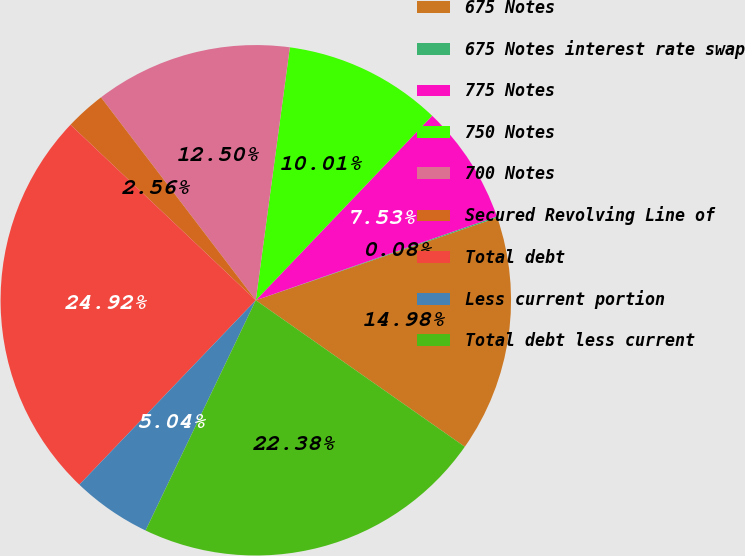<chart> <loc_0><loc_0><loc_500><loc_500><pie_chart><fcel>675 Notes<fcel>675 Notes interest rate swap<fcel>775 Notes<fcel>750 Notes<fcel>700 Notes<fcel>Secured Revolving Line of<fcel>Total debt<fcel>Less current portion<fcel>Total debt less current<nl><fcel>14.98%<fcel>0.08%<fcel>7.53%<fcel>10.01%<fcel>12.5%<fcel>2.56%<fcel>24.92%<fcel>5.04%<fcel>22.38%<nl></chart> 